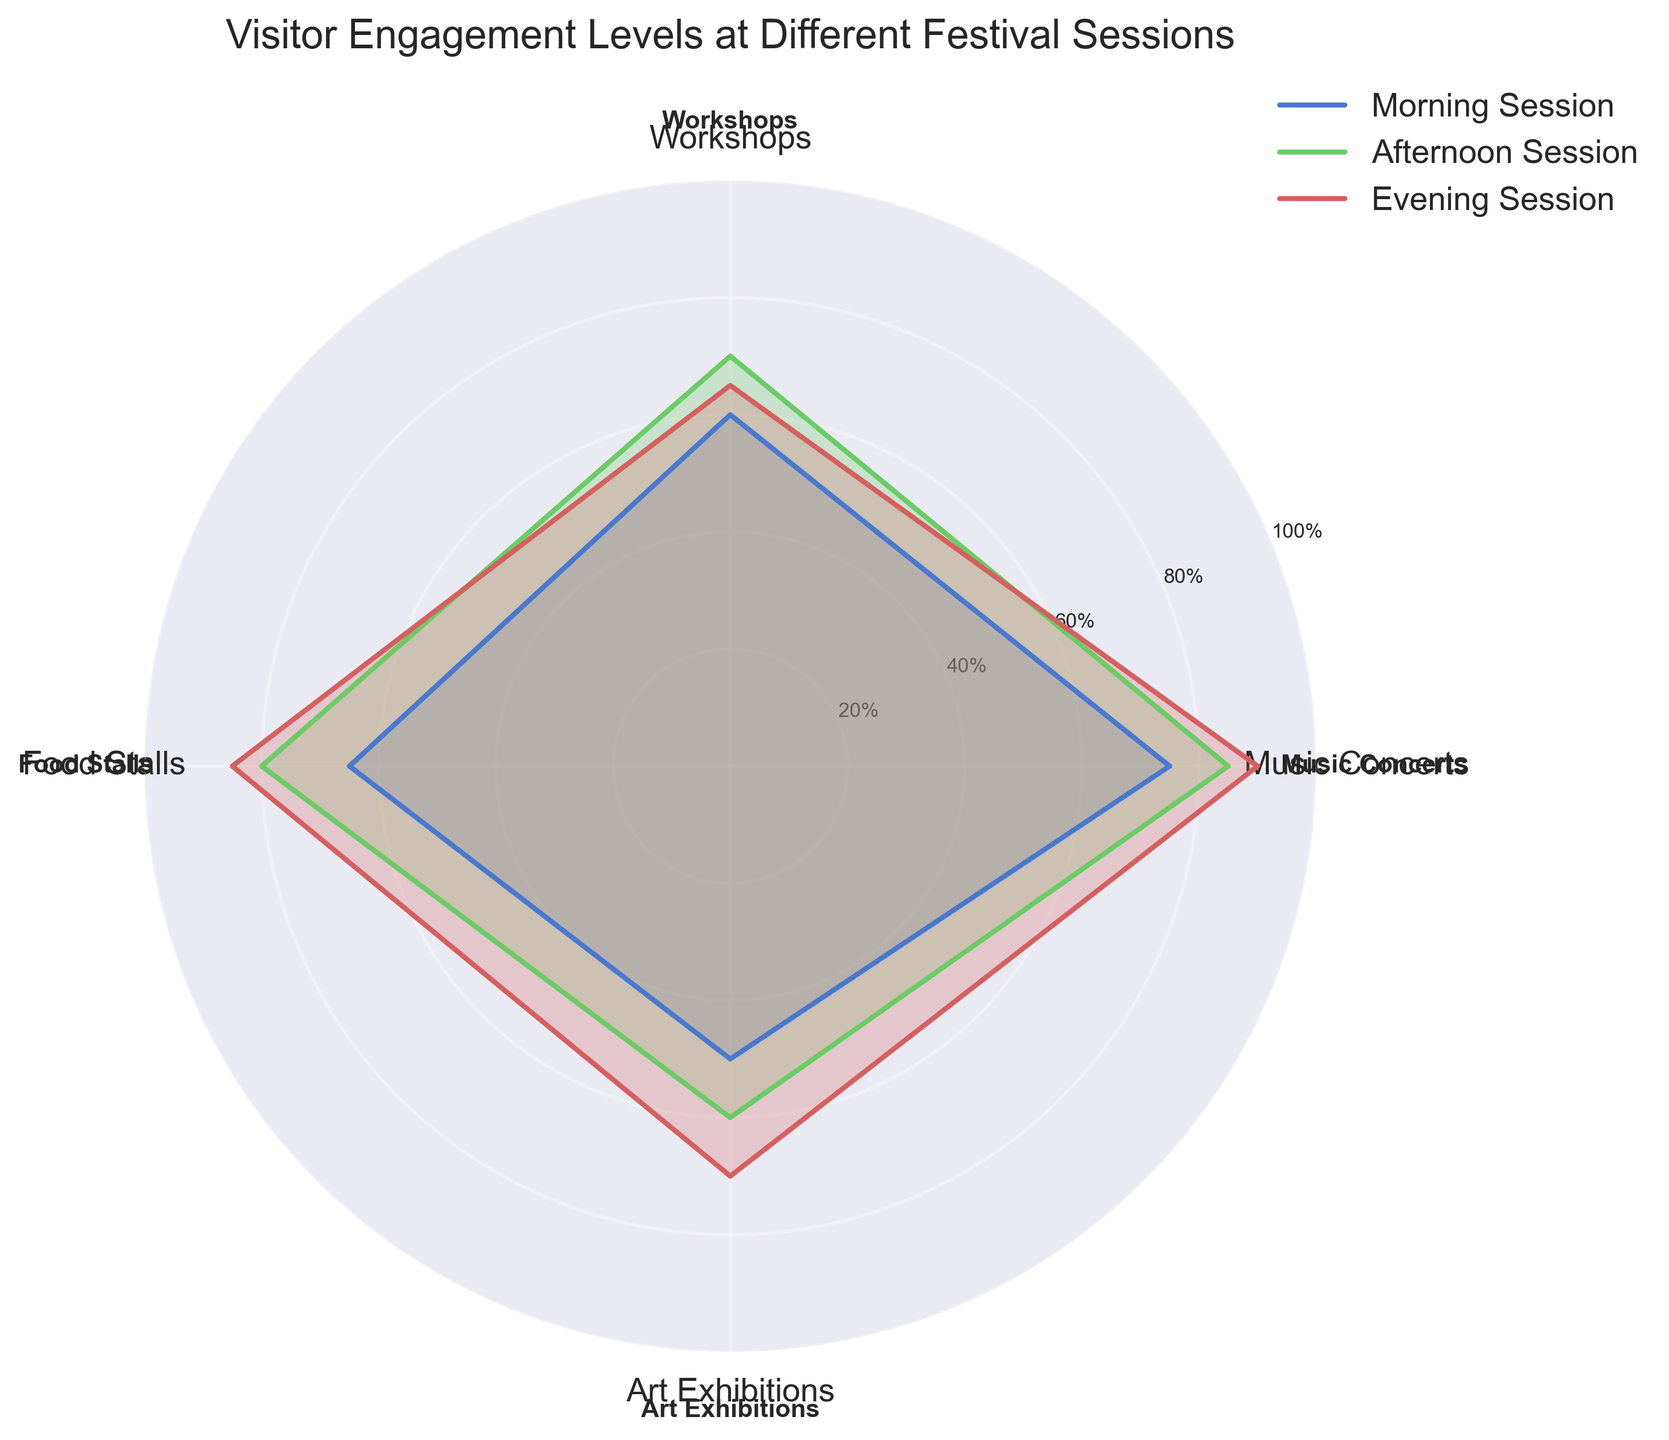What is the title of the radar chart? The title is usually displayed at the top of the figure, describing what the chart represents. In this chart, it reads "Visitor Engagement Levels at Different Festival Sessions".
Answer: Visitor Engagement Levels at Different Festival Sessions How many festival sessions are being compared in the radar chart? The number of lines or areas in the chart that represent different sessions can be counted. Here, there are three colored areas labeled "Morning Session," "Afternoon Session," and "Evening Session".
Answer: Three Which session has the highest engagement at Food Stalls? By examining the sections of the radar chart corresponding to Food Stalls, the session with the highest point along this axis is the one with the largest value. The Evening Session has the highest value for Food Stalls at 85.
Answer: Evening Session What's the difference in engagement for Art Exhibitions between the Morning and Evening Sessions? Locate the Art Exhibitions values for both the Morning (50) and Evening (70) Sessions. The difference is 70 - 50.
Answer: 20 Which session has the lowest engagement level in the Art Exhibitions category? By looking at the Art Exhibitions values on the chart, the Morning Session has the lowest engagement level at 50.
Answer: Morning Session What is the average engagement level across all categories for the Afternoon Session? Add the engagement levels for the Afternoon Session across all categories (85, 70, 80, 60) and divide by the number of categories (4). (85 + 70 + 80 + 60) / 4 = 73.75.
Answer: 73.75 Compare the overall engagement levels between Morning and Evening Sessions. Which one has higher engagement on average? First calculate the average for each session. Morning: (75 + 60 + 65 + 50) / 4 = 62.5. Evening: (90 + 65 + 85 + 70) / 4 = 77.5. The Evening Session has a higher average engagement.
Answer: Evening Session Which category shows the maximum variability in engagement levels across all sessions? To determine this, find the range (difference between maximum and minimum values) in each category. Music Concerts (90 - 75 = 15), Workshops (70 - 60 = 10), Food Stalls (85 - 65 = 20), Art Exhibitions (70 - 50 = 20). Food Stalls and Art Exhibitions both have a range of 20, indicating maximum variability.
Answer: Food Stalls and Art Exhibitions Which session has the most consistent engagement levels across all categories? Look for the session with the smallest range in values. Calculate the range (difference between maximum and minimum values) for each session: Morning Session (75 - 50 = 25), Afternoon Session (85 - 60 = 25), Evening Session (90 - 65 = 25). All sessions have the same range (25) indicating similar consistency.
Answer: All sessions have the same consistency What is the total engagement level for the Evening Session summed across all categories? Add the engagement levels for the Evening Session across all categories. 90 (Music Concerts) + 65 (Workshops) + 85 (Food Stalls) + 70 (Art Exhibitions) = 310.
Answer: 310 